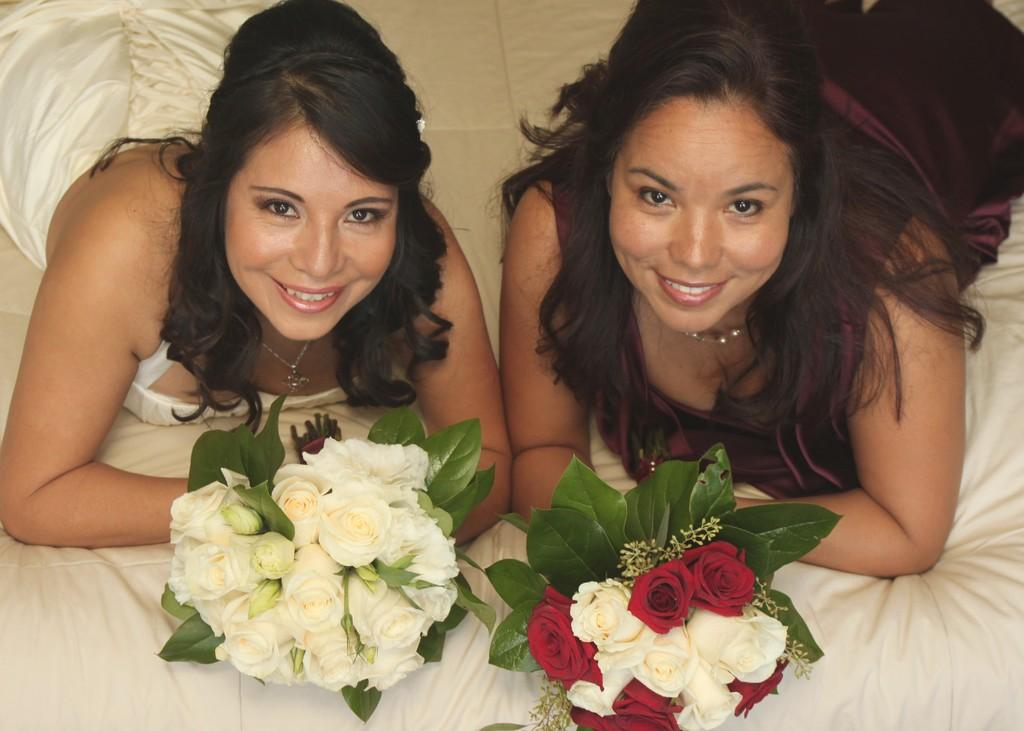How many women are in the image? There are two women in the image. Where are the women positioned in relation to each other? One woman is on the left side, and the other is on the right side. What are the women holding in the image? Both women are holding a set of flowers. What type of tree is supporting the women in the image? There is no tree present in the image, and the women are not being supported by any tree. 